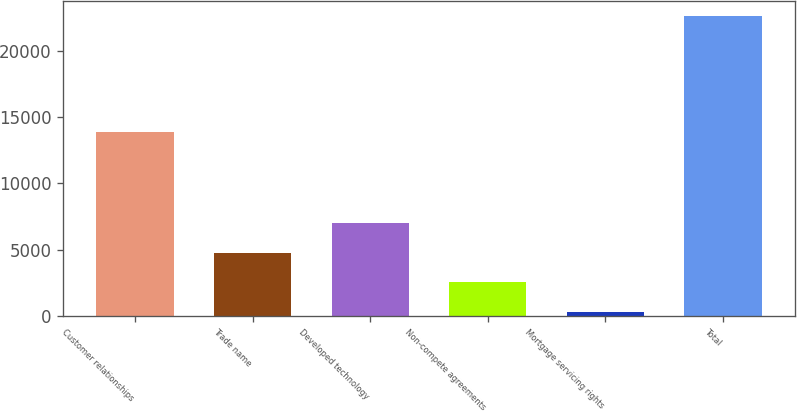Convert chart. <chart><loc_0><loc_0><loc_500><loc_500><bar_chart><fcel>Customer relationships<fcel>Trade name<fcel>Developed technology<fcel>Non-compete agreements<fcel>Mortgage servicing rights<fcel>Total<nl><fcel>13875<fcel>4775<fcel>7012.5<fcel>2537.5<fcel>300<fcel>22675<nl></chart> 